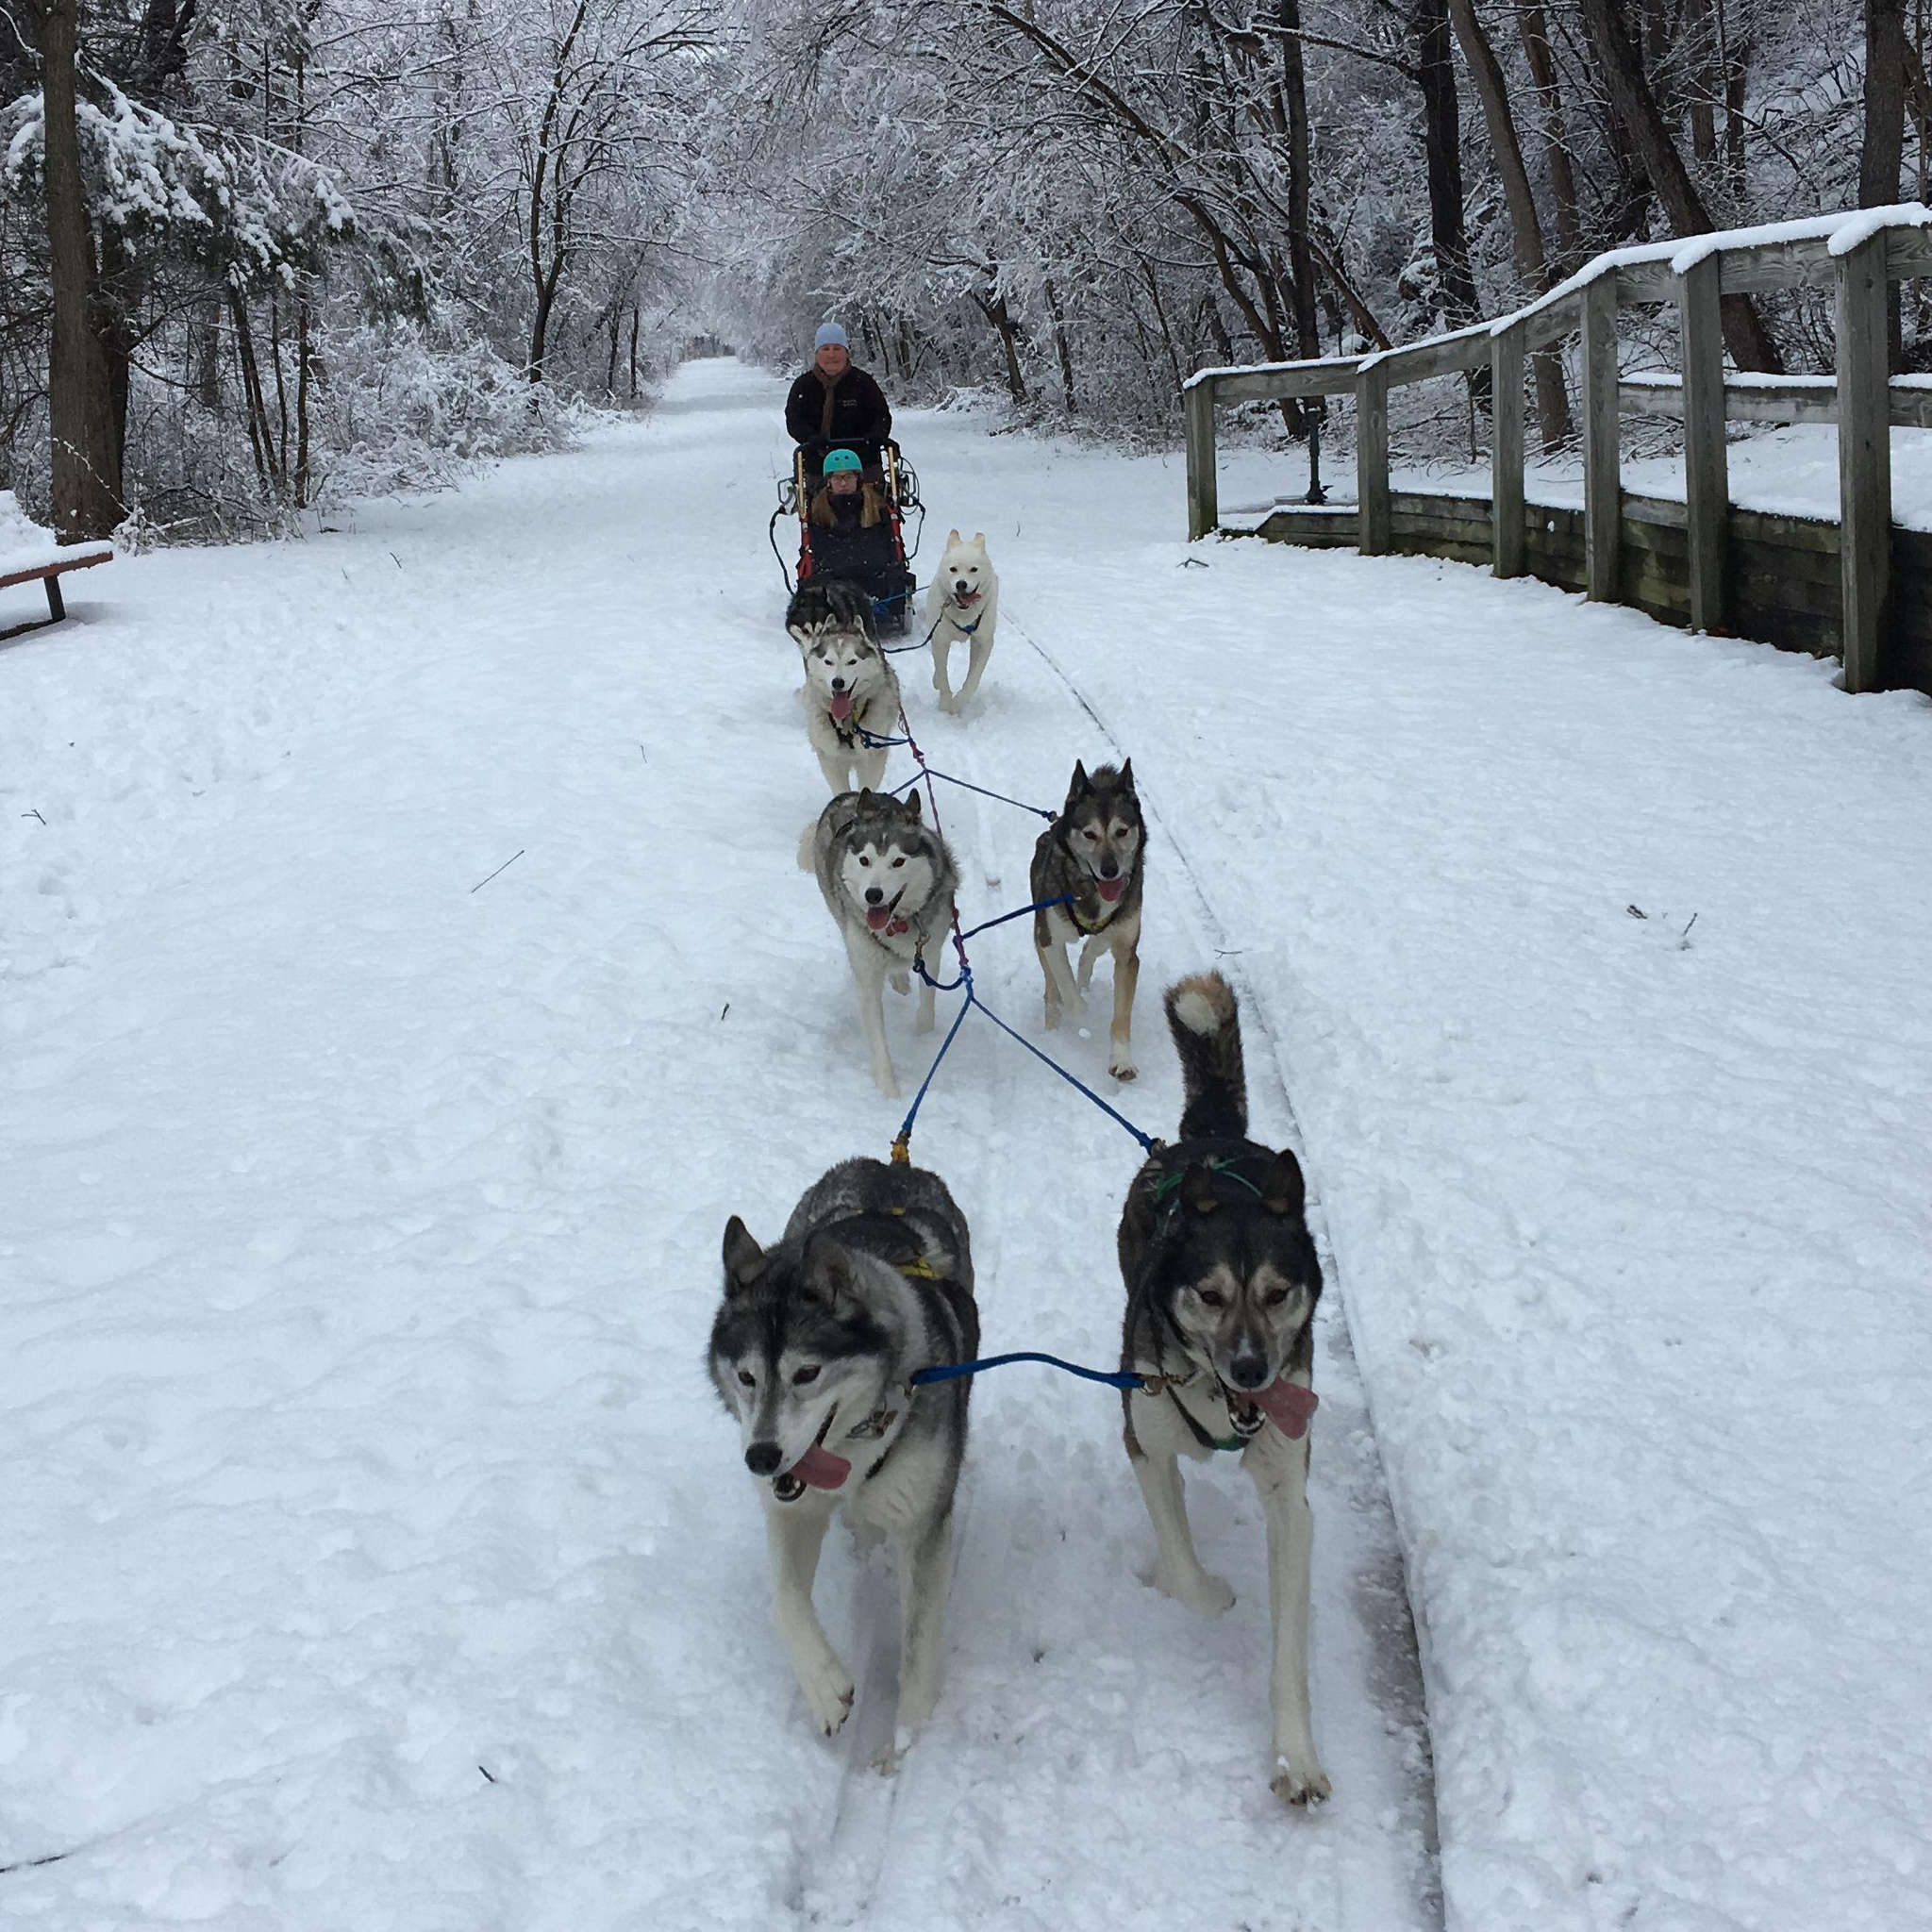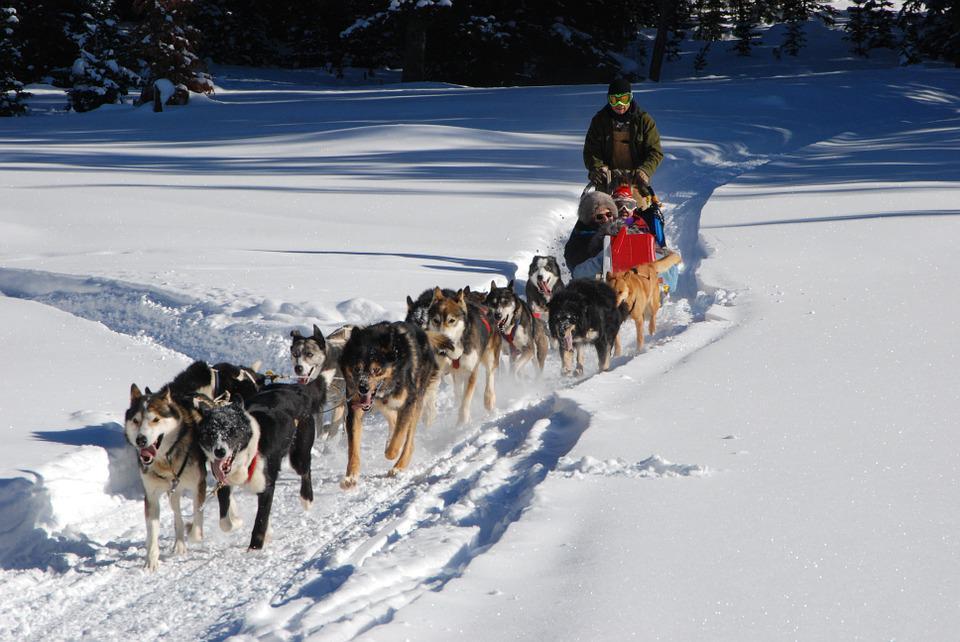The first image is the image on the left, the second image is the image on the right. For the images displayed, is the sentence "A manmade shelter for people is in the background behind a sled dog team moving rightward." factually correct? Answer yes or no. No. The first image is the image on the left, the second image is the image on the right. Given the left and right images, does the statement "The left image contains exactly six sled dogs." hold true? Answer yes or no. Yes. 